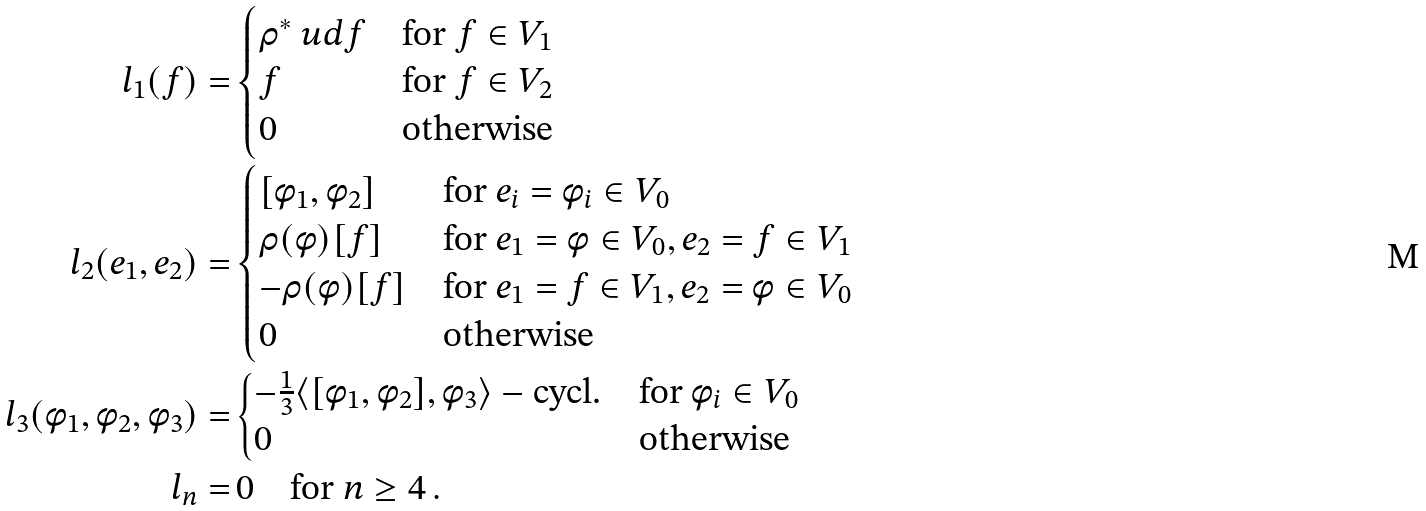<formula> <loc_0><loc_0><loc_500><loc_500>l _ { 1 } ( f ) = & \begin{cases} \rho ^ { * } \ u d f & \text {for } f \in V _ { 1 } \\ f & \text {for } f \in V _ { 2 } \\ 0 & \text {otherwise} \end{cases} \\ l _ { 2 } ( e _ { 1 } , e _ { 2 } ) = & \begin{cases} [ \phi _ { 1 } , \phi _ { 2 } ] & \text {for } e _ { i } = \phi _ { i } \in V _ { 0 } \\ \rho ( \phi ) [ f ] & \text {for } e _ { 1 } = \phi \in V _ { 0 } , e _ { 2 } = f \in V _ { 1 } \\ - \rho ( \phi ) [ f ] & \text {for } e _ { 1 } = f \in V _ { 1 } , e _ { 2 } = \phi \in V _ { 0 } \\ 0 & \text {otherwise} \end{cases} \\ l _ { 3 } ( \phi _ { 1 } , \phi _ { 2 } , \phi _ { 3 } ) = & \begin{cases} - \frac { 1 } { 3 } \langle [ \phi _ { 1 } , \phi _ { 2 } ] , \phi _ { 3 } \rangle - \text {cycl.} & \text {for } \phi _ { i } \in V _ { 0 } \\ 0 & \text {otherwise} \end{cases} \\ l _ { n } = & \, 0 \quad \text {for } n \geq 4 \, .</formula> 